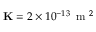<formula> <loc_0><loc_0><loc_500><loc_500>K = 2 \times 1 0 ^ { - 1 3 } \, m ^ { 2 }</formula> 